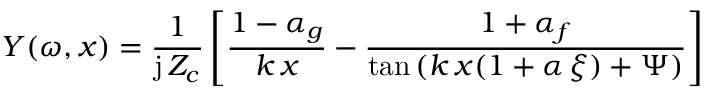<formula> <loc_0><loc_0><loc_500><loc_500>Y ( \omega , x ) = \frac { 1 } { j \, Z _ { c } } \left [ \frac { 1 - \alpha _ { g } } { k \, x } - \frac { 1 + \alpha _ { f } } { \tan { ( k \, x ( 1 + \alpha \, \xi ) + \Psi ) } } \right ]</formula> 